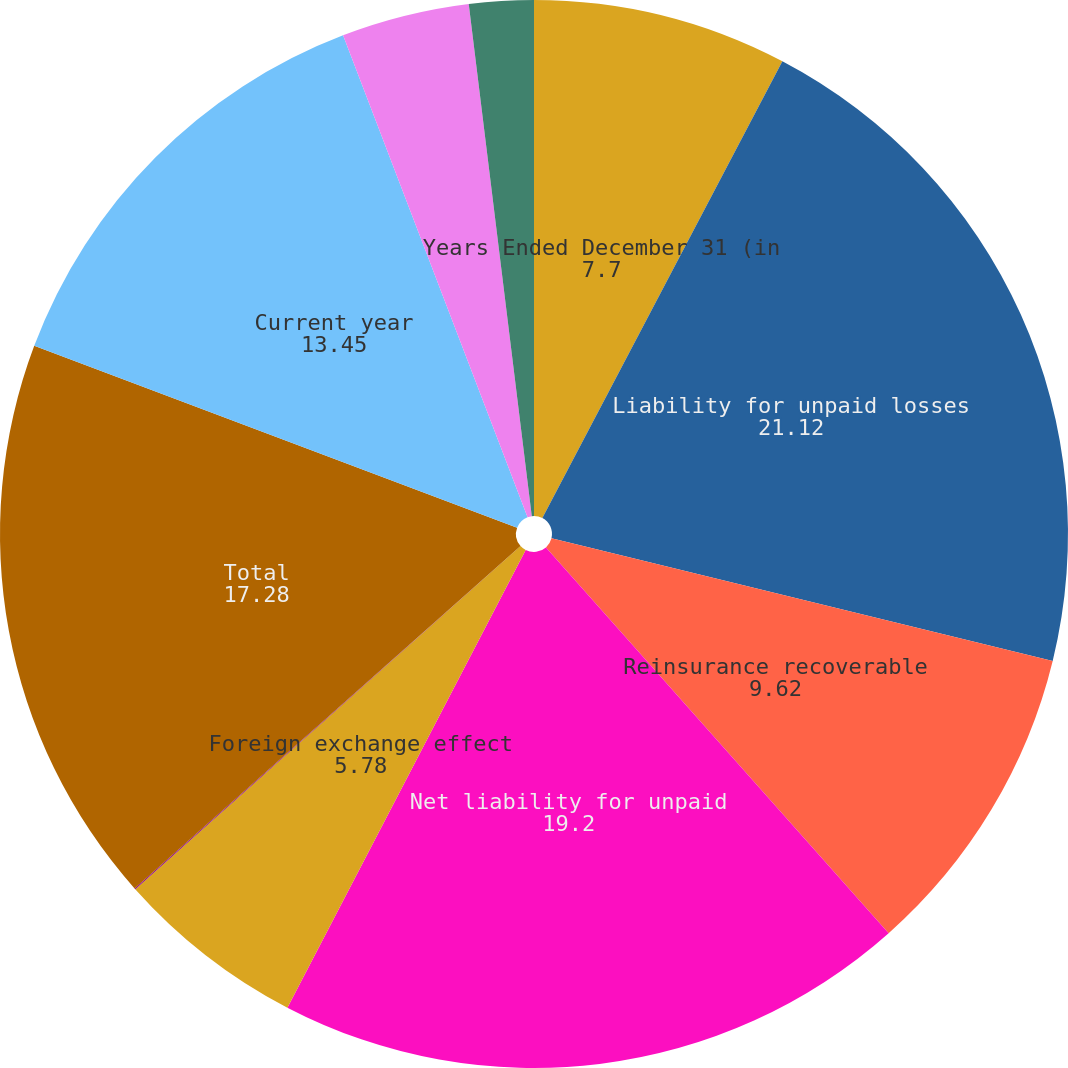Convert chart to OTSL. <chart><loc_0><loc_0><loc_500><loc_500><pie_chart><fcel>Years Ended December 31 (in<fcel>Liability for unpaid losses<fcel>Reinsurance recoverable<fcel>Net liability for unpaid<fcel>Foreign exchange effect<fcel>Changes in net loss reserves<fcel>Total<fcel>Current year<fcel>Prior years excluding discount<fcel>Prior years discount charge<nl><fcel>7.7%<fcel>21.12%<fcel>9.62%<fcel>19.2%<fcel>5.78%<fcel>0.03%<fcel>17.28%<fcel>13.45%<fcel>3.87%<fcel>1.95%<nl></chart> 